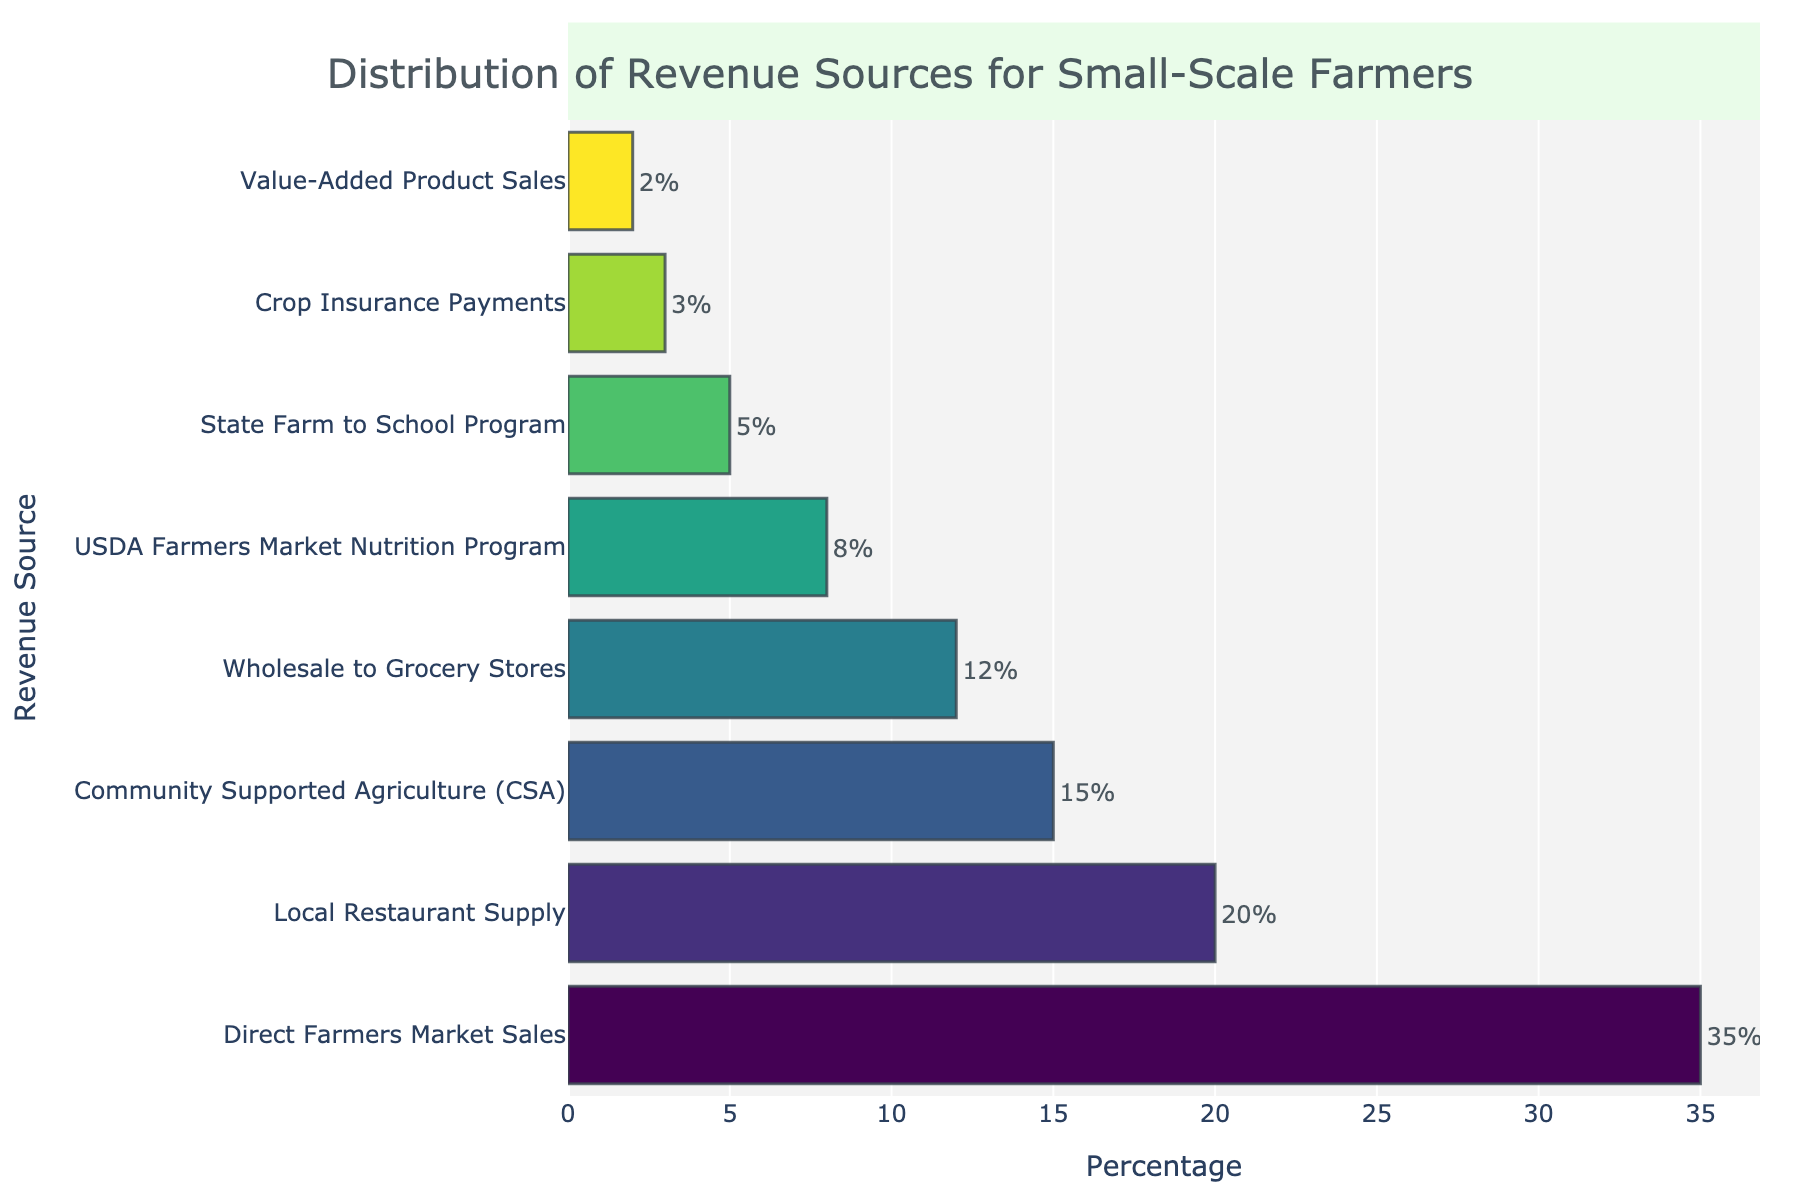Which revenue source contributes the highest percentage? The bar chart shows the percentages of various revenue sources for small-scale farmers. By observing the lengths of the bars, we can see that the "Direct Farmers Market Sales" has the longest bar, indicating the highest percentage contribution.
Answer: Direct Farmers Market Sales Which sources contribute more than 10% each to the total revenue? By examining the bars above the 10% mark on the x-axis, "Direct Farmers Market Sales," "Community Supported Agriculture (CSA)," and "Local Restaurant Supply" contribute more than 10% each.
Answer: Direct Farmers Market Sales, Community Supported Agriculture (CSA), Local Restaurant Supply What is the total percentage contributed by government programs? The relevant government programs are "USDA Farmers Market Nutrition Program," "State Farm to School Program," and "Crop Insurance Payments." Summing their percentages: 8% + 5% + 3% = 16%.
Answer: 16% How does the percentage for Wholesale to Grocery Stores compare to Local Restaurant Supply? Comparing the lengths of the bars, "Wholesale to Grocery Stores" has a shorter bar at 12% compared to "Local Restaurant Supply" at 20%. Therefore, "Wholesale to Grocery Stores" contributes less.
Answer: Wholesale to Grocery Stores is less What is the difference in percentage between Direct Farmers Market Sales and CSA? The percentage for "Direct Farmers Market Sales" is 35%, and for "Community Supported Agriculture (CSA)" is 15%. The difference is 35% - 15% = 20%.
Answer: 20% Which non-government program has the lowest revenue percentage? Observing the lengths of the bars for non-government programs, "Value-Added Product Sales" has the shortest bar at 2%.
Answer: Value-Added Product Sales How does the total percentage of Direct Farmers Market Sales and Local Restaurant Supply compare to Wholesale to Grocery Stores? Sum the percentages of "Direct Farmers Market Sales" (35%) and "Local Restaurant Supply" (20%): 35% + 20% = 55%. Compare this to "Wholesale to Grocery Stores" (12%). 55% is significantly higher than 12%.
Answer: 55% is higher What is the combined percentage of the top three revenue sources? The top three revenue sources are "Direct Farmers Market Sales" (35%), "Local Restaurant Supply" (20%), and "Community Supported Agriculture (CSA)" (15%). Combined percentage: 35% + 20% + 15% = 70%.
Answer: 70% 